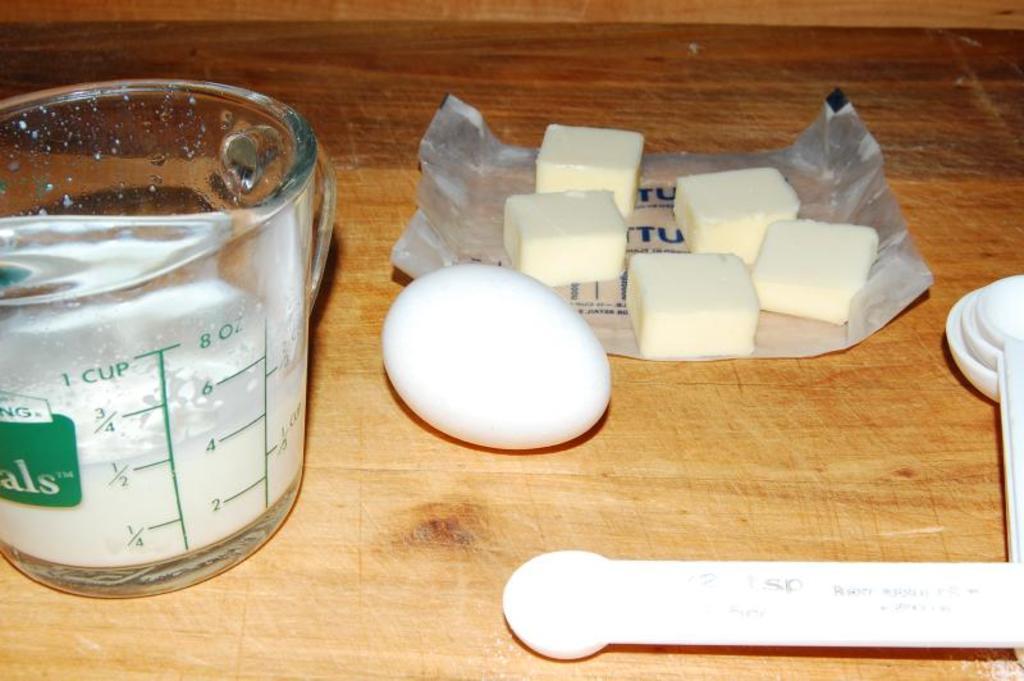How many cups does this measuring cup hold?
Make the answer very short. 1. How many ounces can the measuring cup hold?
Keep it short and to the point. 8. 